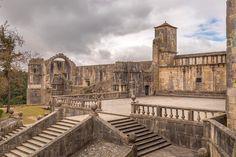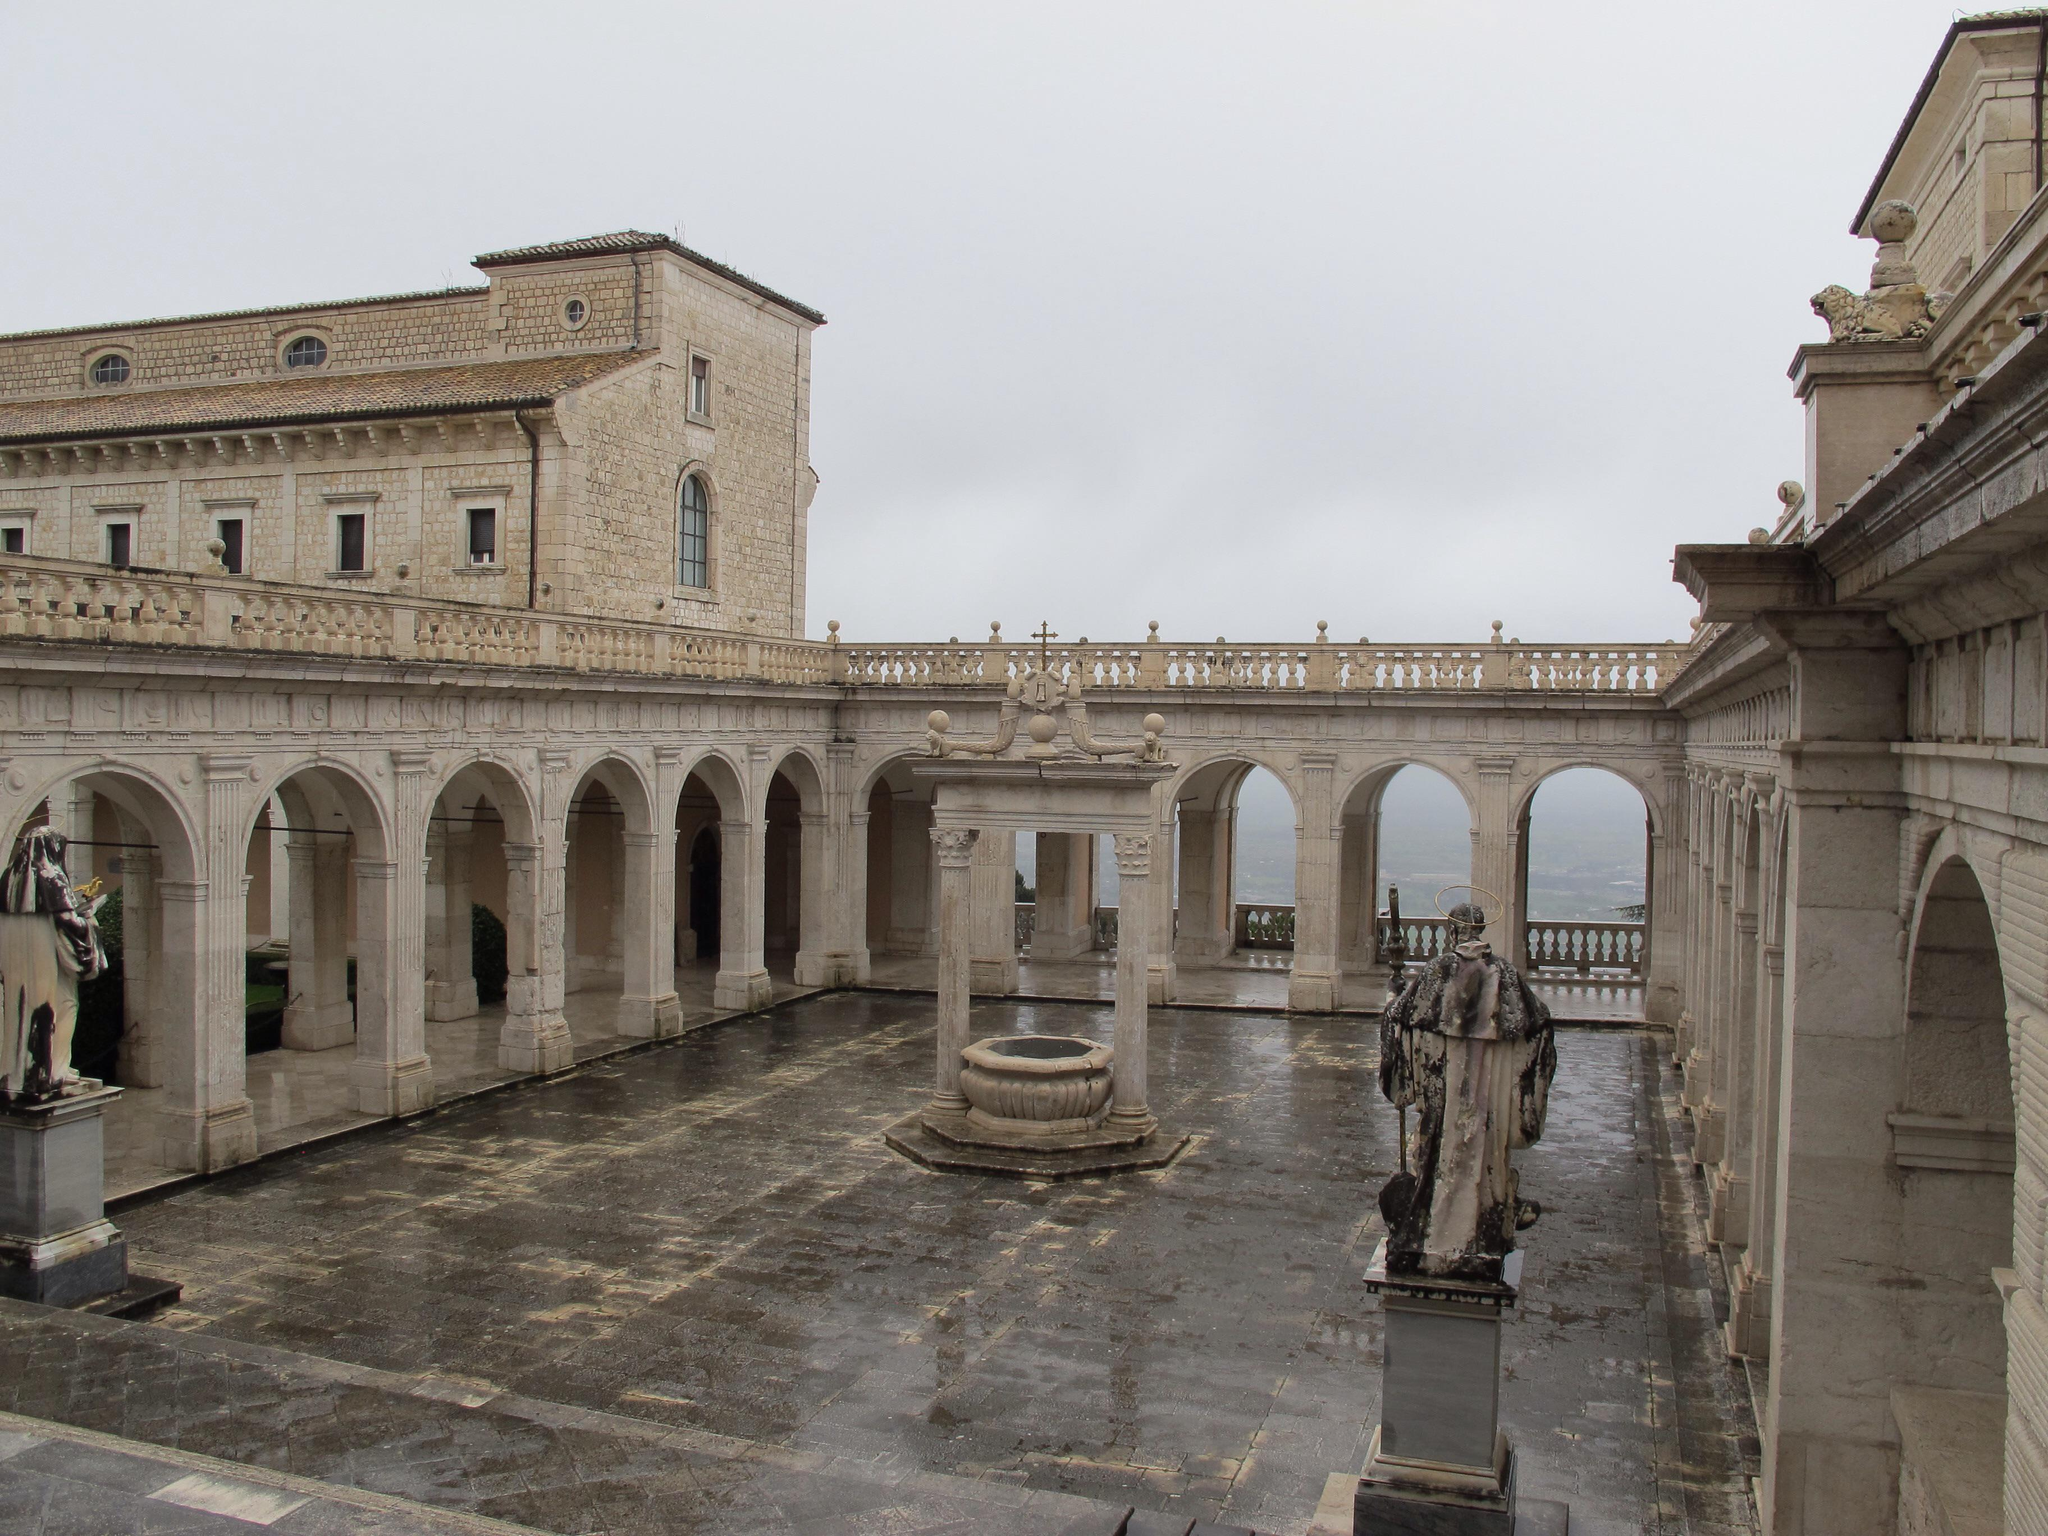The first image is the image on the left, the second image is the image on the right. Considering the images on both sides, is "There is a round window on top of the main door of a cathedral in the left image." valid? Answer yes or no. No. The first image is the image on the left, the second image is the image on the right. Evaluate the accuracy of this statement regarding the images: "There are humans in at least one of the images.". Is it true? Answer yes or no. No. 